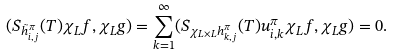<formula> <loc_0><loc_0><loc_500><loc_500>( S _ { \tilde { h } ^ { \pi } _ { i , j } } ( T ) \chi _ { L } f , \chi _ { L } g ) = \sum _ { k = 1 } ^ { \infty } ( S _ { \chi _ { L \times L } h ^ { \pi } _ { k , j } } ( T ) u ^ { \pi } _ { i , k } \chi _ { L } f , \chi _ { L } g ) = 0 .</formula> 